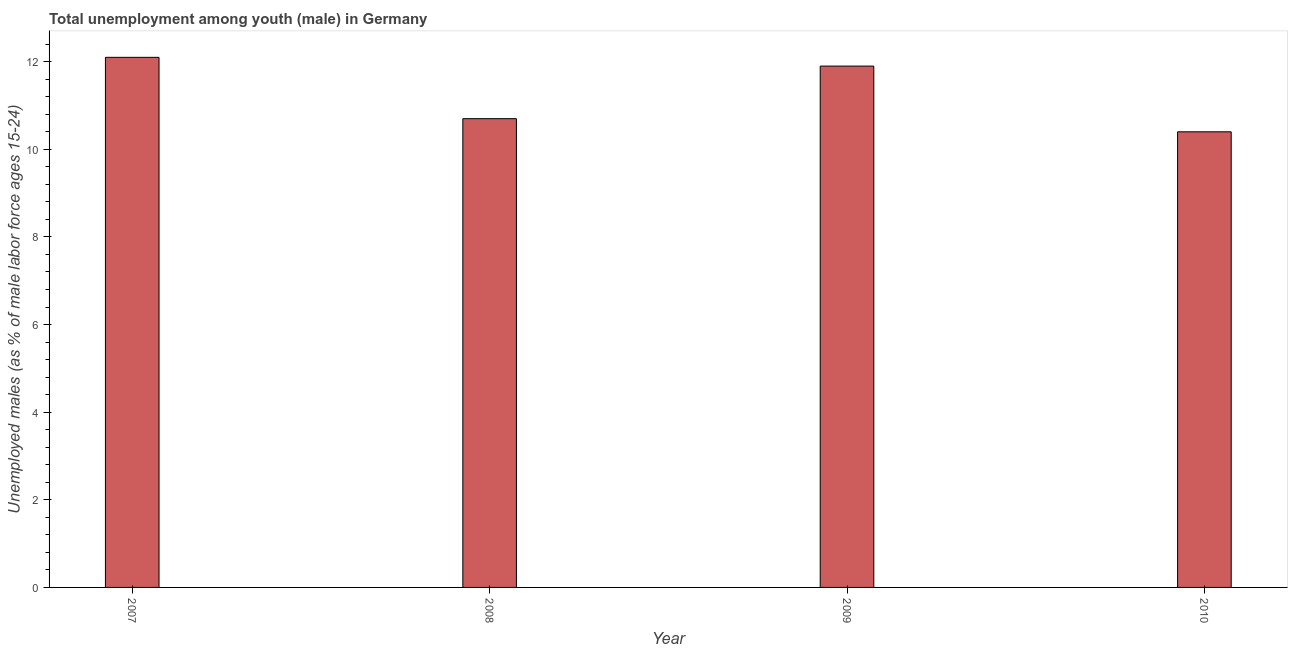Does the graph contain any zero values?
Ensure brevity in your answer.  No. What is the title of the graph?
Your response must be concise. Total unemployment among youth (male) in Germany. What is the label or title of the Y-axis?
Your response must be concise. Unemployed males (as % of male labor force ages 15-24). What is the unemployed male youth population in 2008?
Your answer should be compact. 10.7. Across all years, what is the maximum unemployed male youth population?
Make the answer very short. 12.1. Across all years, what is the minimum unemployed male youth population?
Offer a very short reply. 10.4. In which year was the unemployed male youth population maximum?
Keep it short and to the point. 2007. What is the sum of the unemployed male youth population?
Offer a terse response. 45.1. What is the average unemployed male youth population per year?
Your response must be concise. 11.28. What is the median unemployed male youth population?
Provide a short and direct response. 11.3. In how many years, is the unemployed male youth population greater than 4 %?
Provide a succinct answer. 4. Do a majority of the years between 2007 and 2010 (inclusive) have unemployed male youth population greater than 8.4 %?
Provide a short and direct response. Yes. What is the ratio of the unemployed male youth population in 2008 to that in 2010?
Your response must be concise. 1.03. Is the unemployed male youth population in 2008 less than that in 2010?
Offer a very short reply. No. Is the difference between the unemployed male youth population in 2009 and 2010 greater than the difference between any two years?
Your answer should be compact. No. What is the difference between the highest and the second highest unemployed male youth population?
Offer a very short reply. 0.2. Is the sum of the unemployed male youth population in 2008 and 2010 greater than the maximum unemployed male youth population across all years?
Provide a short and direct response. Yes. How many years are there in the graph?
Ensure brevity in your answer.  4. What is the difference between two consecutive major ticks on the Y-axis?
Make the answer very short. 2. What is the Unemployed males (as % of male labor force ages 15-24) of 2007?
Provide a succinct answer. 12.1. What is the Unemployed males (as % of male labor force ages 15-24) of 2008?
Offer a very short reply. 10.7. What is the Unemployed males (as % of male labor force ages 15-24) of 2009?
Keep it short and to the point. 11.9. What is the Unemployed males (as % of male labor force ages 15-24) in 2010?
Your response must be concise. 10.4. What is the ratio of the Unemployed males (as % of male labor force ages 15-24) in 2007 to that in 2008?
Your response must be concise. 1.13. What is the ratio of the Unemployed males (as % of male labor force ages 15-24) in 2007 to that in 2010?
Give a very brief answer. 1.16. What is the ratio of the Unemployed males (as % of male labor force ages 15-24) in 2008 to that in 2009?
Give a very brief answer. 0.9. What is the ratio of the Unemployed males (as % of male labor force ages 15-24) in 2008 to that in 2010?
Make the answer very short. 1.03. What is the ratio of the Unemployed males (as % of male labor force ages 15-24) in 2009 to that in 2010?
Your answer should be very brief. 1.14. 